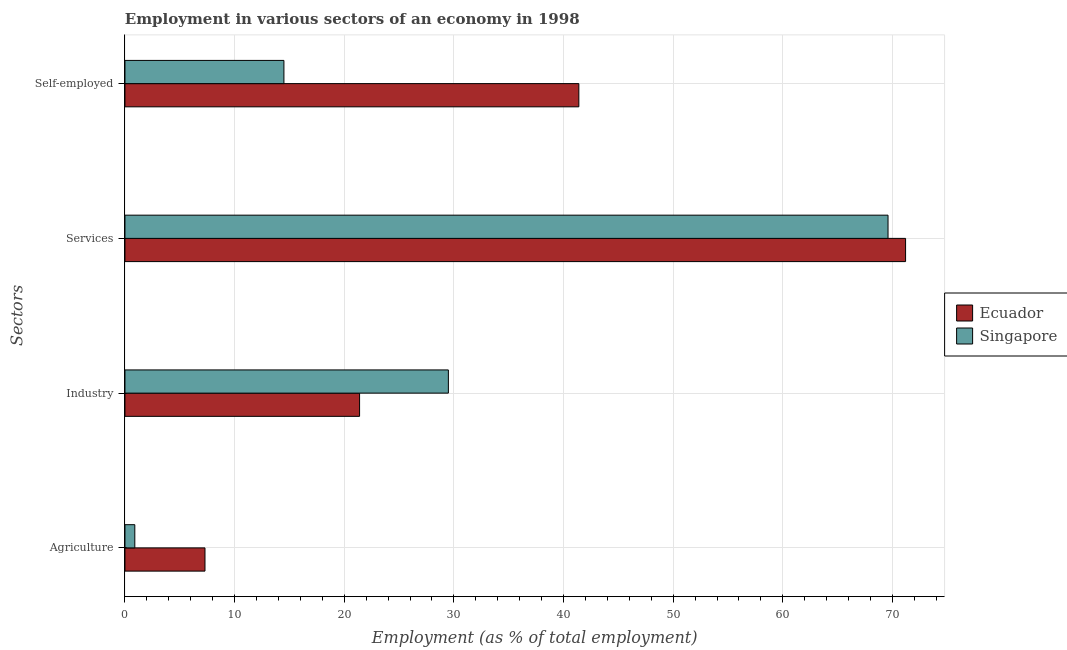How many different coloured bars are there?
Give a very brief answer. 2. How many groups of bars are there?
Offer a terse response. 4. Are the number of bars on each tick of the Y-axis equal?
Offer a very short reply. Yes. What is the label of the 3rd group of bars from the top?
Make the answer very short. Industry. Across all countries, what is the maximum percentage of workers in agriculture?
Offer a very short reply. 7.3. Across all countries, what is the minimum percentage of self employed workers?
Offer a very short reply. 14.5. In which country was the percentage of workers in services maximum?
Provide a succinct answer. Ecuador. In which country was the percentage of workers in industry minimum?
Give a very brief answer. Ecuador. What is the total percentage of workers in services in the graph?
Provide a succinct answer. 140.8. What is the difference between the percentage of self employed workers in Ecuador and that in Singapore?
Give a very brief answer. 26.9. What is the difference between the percentage of self employed workers in Singapore and the percentage of workers in agriculture in Ecuador?
Ensure brevity in your answer.  7.2. What is the average percentage of self employed workers per country?
Your answer should be very brief. 27.95. What is the difference between the percentage of workers in services and percentage of self employed workers in Singapore?
Ensure brevity in your answer.  55.1. What is the ratio of the percentage of workers in industry in Ecuador to that in Singapore?
Make the answer very short. 0.73. Is the difference between the percentage of workers in services in Singapore and Ecuador greater than the difference between the percentage of workers in industry in Singapore and Ecuador?
Ensure brevity in your answer.  No. What is the difference between the highest and the second highest percentage of self employed workers?
Your answer should be compact. 26.9. What is the difference between the highest and the lowest percentage of workers in services?
Provide a short and direct response. 1.6. In how many countries, is the percentage of workers in agriculture greater than the average percentage of workers in agriculture taken over all countries?
Keep it short and to the point. 1. Is it the case that in every country, the sum of the percentage of workers in agriculture and percentage of self employed workers is greater than the sum of percentage of workers in industry and percentage of workers in services?
Ensure brevity in your answer.  No. What does the 1st bar from the top in Services represents?
Offer a terse response. Singapore. What does the 1st bar from the bottom in Services represents?
Make the answer very short. Ecuador. How many bars are there?
Offer a terse response. 8. Are all the bars in the graph horizontal?
Provide a short and direct response. Yes. How many countries are there in the graph?
Offer a very short reply. 2. Does the graph contain any zero values?
Make the answer very short. No. What is the title of the graph?
Provide a succinct answer. Employment in various sectors of an economy in 1998. Does "OECD members" appear as one of the legend labels in the graph?
Your answer should be compact. No. What is the label or title of the X-axis?
Your answer should be very brief. Employment (as % of total employment). What is the label or title of the Y-axis?
Provide a short and direct response. Sectors. What is the Employment (as % of total employment) in Ecuador in Agriculture?
Offer a terse response. 7.3. What is the Employment (as % of total employment) of Singapore in Agriculture?
Give a very brief answer. 0.9. What is the Employment (as % of total employment) in Ecuador in Industry?
Give a very brief answer. 21.4. What is the Employment (as % of total employment) in Singapore in Industry?
Provide a succinct answer. 29.5. What is the Employment (as % of total employment) of Ecuador in Services?
Provide a succinct answer. 71.2. What is the Employment (as % of total employment) of Singapore in Services?
Your answer should be compact. 69.6. What is the Employment (as % of total employment) in Ecuador in Self-employed?
Your answer should be very brief. 41.4. What is the Employment (as % of total employment) in Singapore in Self-employed?
Your response must be concise. 14.5. Across all Sectors, what is the maximum Employment (as % of total employment) of Ecuador?
Your answer should be compact. 71.2. Across all Sectors, what is the maximum Employment (as % of total employment) in Singapore?
Give a very brief answer. 69.6. Across all Sectors, what is the minimum Employment (as % of total employment) in Ecuador?
Your response must be concise. 7.3. Across all Sectors, what is the minimum Employment (as % of total employment) in Singapore?
Provide a succinct answer. 0.9. What is the total Employment (as % of total employment) in Ecuador in the graph?
Your answer should be very brief. 141.3. What is the total Employment (as % of total employment) of Singapore in the graph?
Make the answer very short. 114.5. What is the difference between the Employment (as % of total employment) in Ecuador in Agriculture and that in Industry?
Ensure brevity in your answer.  -14.1. What is the difference between the Employment (as % of total employment) in Singapore in Agriculture and that in Industry?
Offer a terse response. -28.6. What is the difference between the Employment (as % of total employment) in Ecuador in Agriculture and that in Services?
Provide a succinct answer. -63.9. What is the difference between the Employment (as % of total employment) of Singapore in Agriculture and that in Services?
Your answer should be compact. -68.7. What is the difference between the Employment (as % of total employment) of Ecuador in Agriculture and that in Self-employed?
Make the answer very short. -34.1. What is the difference between the Employment (as % of total employment) of Ecuador in Industry and that in Services?
Provide a succinct answer. -49.8. What is the difference between the Employment (as % of total employment) in Singapore in Industry and that in Services?
Provide a short and direct response. -40.1. What is the difference between the Employment (as % of total employment) of Singapore in Industry and that in Self-employed?
Provide a succinct answer. 15. What is the difference between the Employment (as % of total employment) in Ecuador in Services and that in Self-employed?
Your response must be concise. 29.8. What is the difference between the Employment (as % of total employment) in Singapore in Services and that in Self-employed?
Your answer should be very brief. 55.1. What is the difference between the Employment (as % of total employment) of Ecuador in Agriculture and the Employment (as % of total employment) of Singapore in Industry?
Provide a short and direct response. -22.2. What is the difference between the Employment (as % of total employment) of Ecuador in Agriculture and the Employment (as % of total employment) of Singapore in Services?
Your answer should be compact. -62.3. What is the difference between the Employment (as % of total employment) of Ecuador in Agriculture and the Employment (as % of total employment) of Singapore in Self-employed?
Provide a short and direct response. -7.2. What is the difference between the Employment (as % of total employment) in Ecuador in Industry and the Employment (as % of total employment) in Singapore in Services?
Provide a succinct answer. -48.2. What is the difference between the Employment (as % of total employment) in Ecuador in Industry and the Employment (as % of total employment) in Singapore in Self-employed?
Provide a short and direct response. 6.9. What is the difference between the Employment (as % of total employment) of Ecuador in Services and the Employment (as % of total employment) of Singapore in Self-employed?
Give a very brief answer. 56.7. What is the average Employment (as % of total employment) of Ecuador per Sectors?
Provide a succinct answer. 35.33. What is the average Employment (as % of total employment) of Singapore per Sectors?
Offer a terse response. 28.62. What is the difference between the Employment (as % of total employment) of Ecuador and Employment (as % of total employment) of Singapore in Industry?
Keep it short and to the point. -8.1. What is the difference between the Employment (as % of total employment) of Ecuador and Employment (as % of total employment) of Singapore in Self-employed?
Offer a terse response. 26.9. What is the ratio of the Employment (as % of total employment) of Ecuador in Agriculture to that in Industry?
Your response must be concise. 0.34. What is the ratio of the Employment (as % of total employment) in Singapore in Agriculture to that in Industry?
Your response must be concise. 0.03. What is the ratio of the Employment (as % of total employment) of Ecuador in Agriculture to that in Services?
Provide a short and direct response. 0.1. What is the ratio of the Employment (as % of total employment) of Singapore in Agriculture to that in Services?
Provide a short and direct response. 0.01. What is the ratio of the Employment (as % of total employment) of Ecuador in Agriculture to that in Self-employed?
Give a very brief answer. 0.18. What is the ratio of the Employment (as % of total employment) in Singapore in Agriculture to that in Self-employed?
Your answer should be compact. 0.06. What is the ratio of the Employment (as % of total employment) of Ecuador in Industry to that in Services?
Ensure brevity in your answer.  0.3. What is the ratio of the Employment (as % of total employment) of Singapore in Industry to that in Services?
Your answer should be very brief. 0.42. What is the ratio of the Employment (as % of total employment) of Ecuador in Industry to that in Self-employed?
Give a very brief answer. 0.52. What is the ratio of the Employment (as % of total employment) of Singapore in Industry to that in Self-employed?
Offer a very short reply. 2.03. What is the ratio of the Employment (as % of total employment) in Ecuador in Services to that in Self-employed?
Give a very brief answer. 1.72. What is the ratio of the Employment (as % of total employment) of Singapore in Services to that in Self-employed?
Your response must be concise. 4.8. What is the difference between the highest and the second highest Employment (as % of total employment) of Ecuador?
Offer a very short reply. 29.8. What is the difference between the highest and the second highest Employment (as % of total employment) in Singapore?
Ensure brevity in your answer.  40.1. What is the difference between the highest and the lowest Employment (as % of total employment) of Ecuador?
Your answer should be very brief. 63.9. What is the difference between the highest and the lowest Employment (as % of total employment) in Singapore?
Your response must be concise. 68.7. 